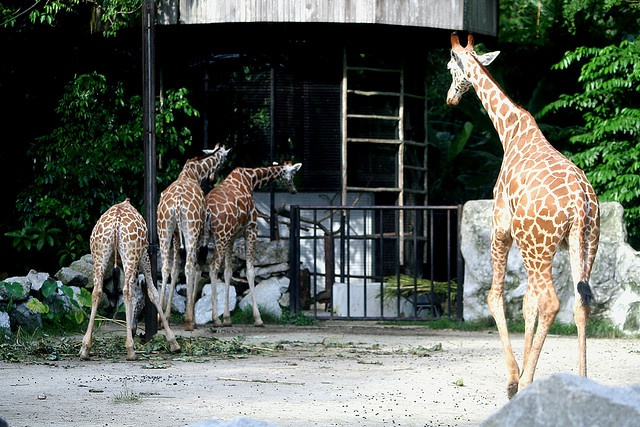Describe the objects in this image and their specific colors. I can see giraffe in black, ivory, and tan tones, giraffe in black, darkgray, gray, and lightgray tones, giraffe in black, gray, darkgray, and maroon tones, and giraffe in black, darkgray, gray, and lavender tones in this image. 